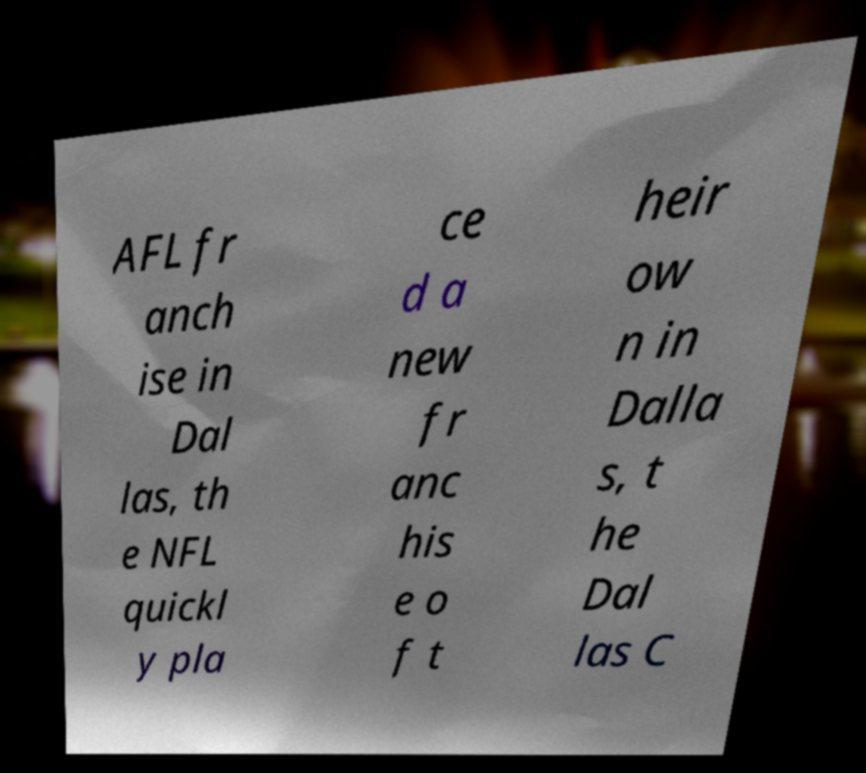There's text embedded in this image that I need extracted. Can you transcribe it verbatim? AFL fr anch ise in Dal las, th e NFL quickl y pla ce d a new fr anc his e o f t heir ow n in Dalla s, t he Dal las C 